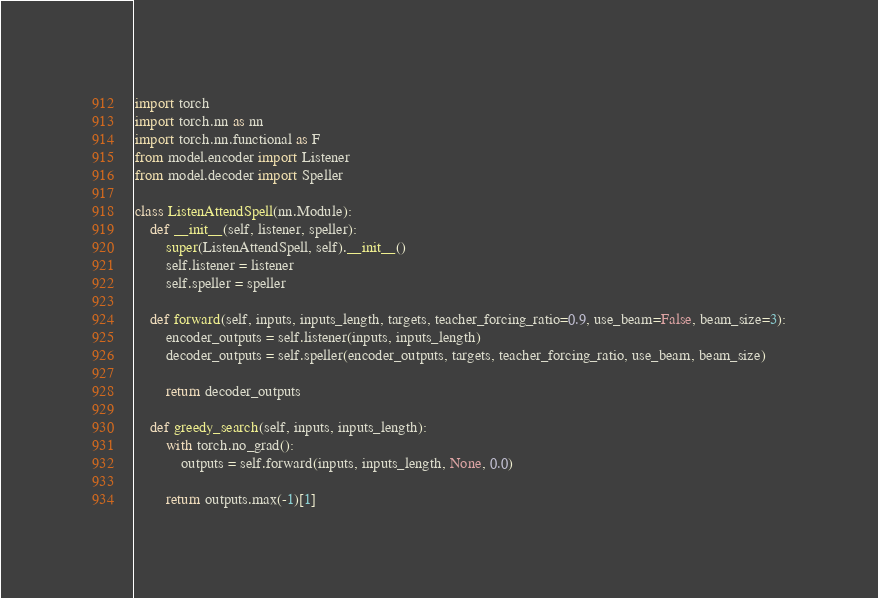Convert code to text. <code><loc_0><loc_0><loc_500><loc_500><_Python_>import torch
import torch.nn as nn
import torch.nn.functional as F
from model.encoder import Listener
from model.decoder import Speller

class ListenAttendSpell(nn.Module):
    def __init__(self, listener, speller):
        super(ListenAttendSpell, self).__init__()
        self.listener = listener
        self.speller = speller

    def forward(self, inputs, inputs_length, targets, teacher_forcing_ratio=0.9, use_beam=False, beam_size=3):
        encoder_outputs = self.listener(inputs, inputs_length)
        decoder_outputs = self.speller(encoder_outputs, targets, teacher_forcing_ratio, use_beam, beam_size)

        return decoder_outputs

    def greedy_search(self, inputs, inputs_length):
        with torch.no_grad():
            outputs = self.forward(inputs, inputs_length, None, 0.0)

        return outputs.max(-1)[1]
</code> 